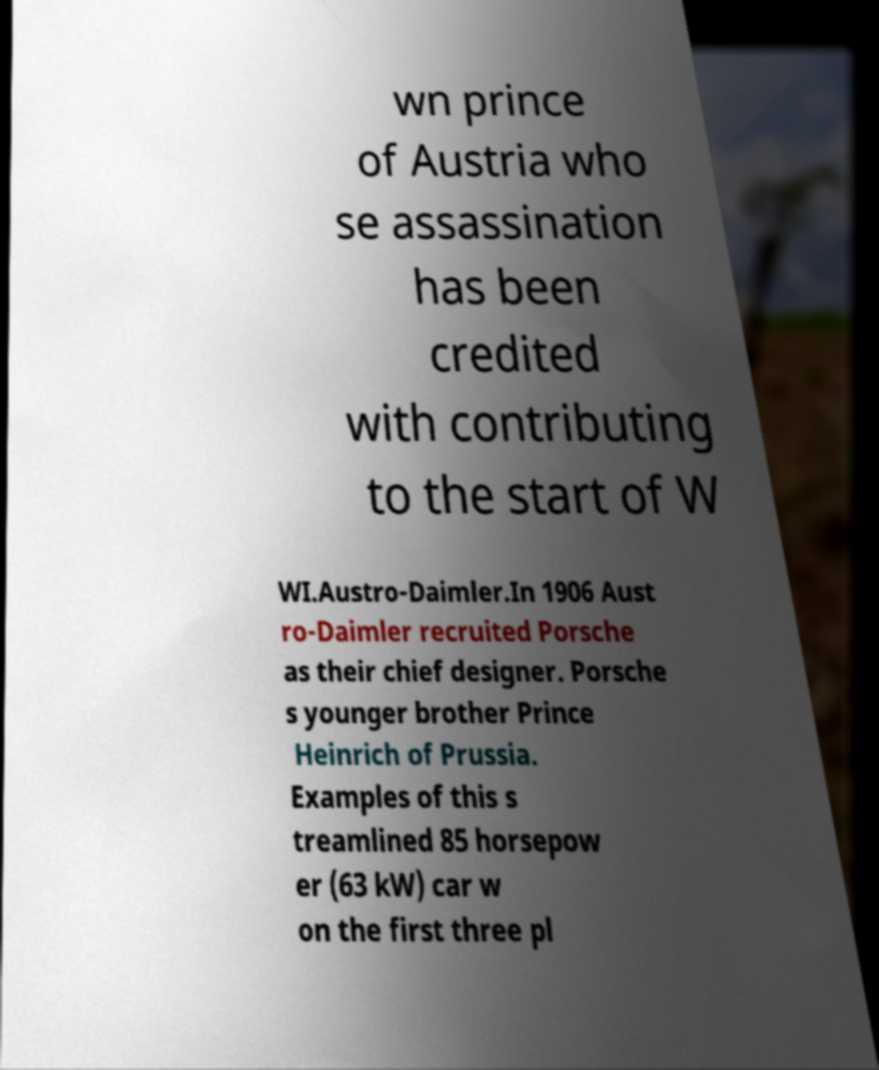Could you assist in decoding the text presented in this image and type it out clearly? wn prince of Austria who se assassination has been credited with contributing to the start of W WI.Austro-Daimler.In 1906 Aust ro-Daimler recruited Porsche as their chief designer. Porsche s younger brother Prince Heinrich of Prussia. Examples of this s treamlined 85 horsepow er (63 kW) car w on the first three pl 